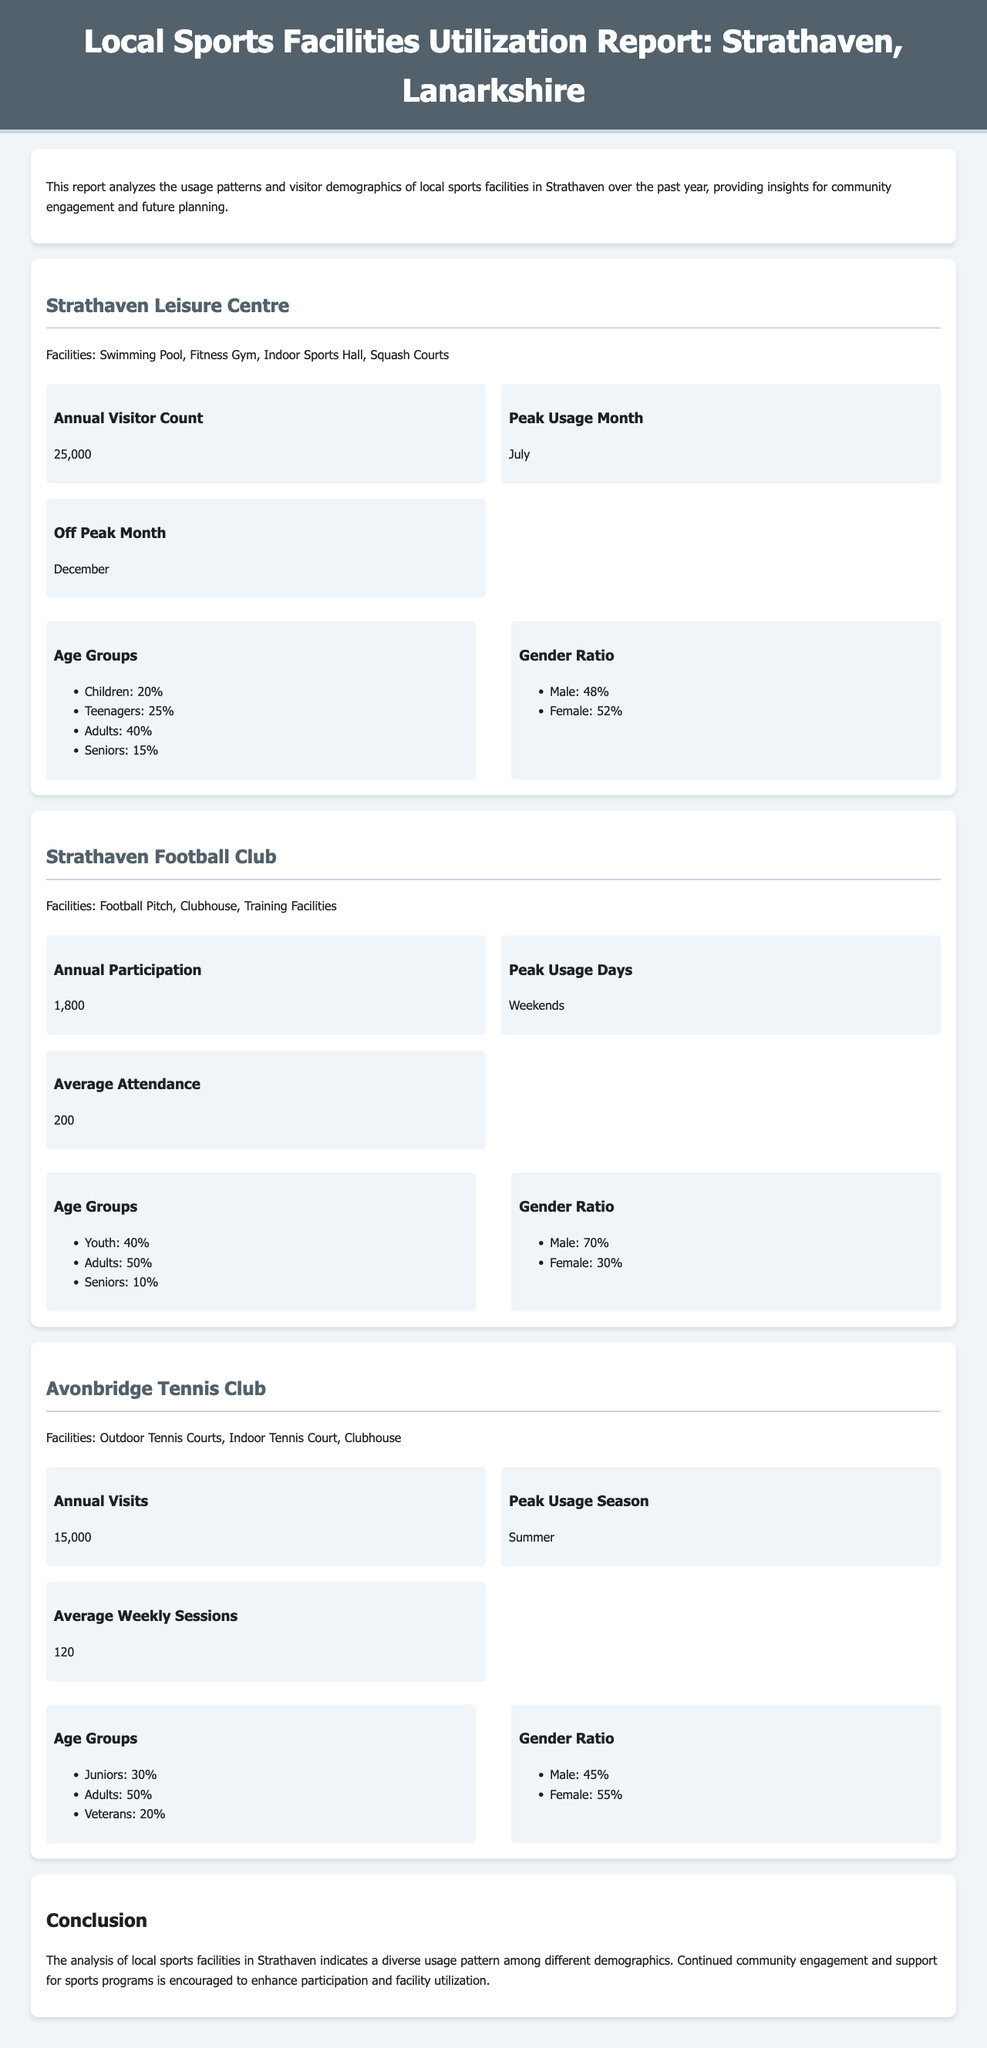What is the annual visitor count for Strathaven Leisure Centre? The annual visitor count is highlighted in the report for Strathaven Leisure Centre, which is 25,000.
Answer: 25,000 What is the peak usage month for the Strathaven Leisure Centre? The document specifies that the peak usage month for Strathaven Leisure Centre is July.
Answer: July How many annual visits does Avonbridge Tennis Club have? The report outlines the annual visits for Avonbridge Tennis Club, which is 15,000.
Answer: 15,000 What percentage of visitors to Strathaven Football Club are adults? The age group breakdown for Strathaven Football Club indicates that 50% of participants are adults.
Answer: 50% What facilities are available at the Avonbridge Tennis Club? The document lists the facilities at Avonbridge Tennis Club, which include outdoor tennis courts, indoor tennis court, and clubhouse.
Answer: Outdoor Tennis Courts, Indoor Tennis Court, Clubhouse What percentage of users at Strathaven Leisure Centre are teenagers? The age group data for Strathaven Leisure Centre shows that 25% of users are teenagers.
Answer: 25% Which facility has the highest annual visitor count? The report compares the annual visitor counts, where Strathaven Leisure Centre has the highest with 25,000.
Answer: Strathaven Leisure Centre What is the gender ratio of participants at Avonbridge Tennis Club? The document provides the gender ratio for Avonbridge Tennis Club, indicating that males make up 45% and females 55%.
Answer: Male: 45%, Female: 55% In which month does the Strathaven Leisure Centre experience the lowest usage? The off-peak month for Strathaven Leisure Centre is specified as December.
Answer: December 